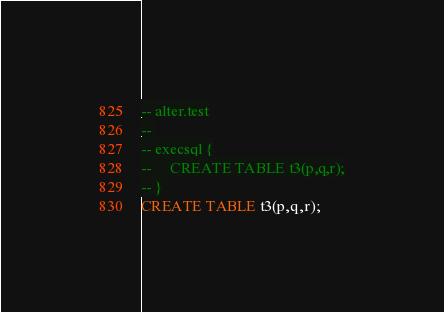Convert code to text. <code><loc_0><loc_0><loc_500><loc_500><_SQL_>-- alter.test
-- 
-- execsql {
--     CREATE TABLE t3(p,q,r);
-- }
CREATE TABLE t3(p,q,r);</code> 